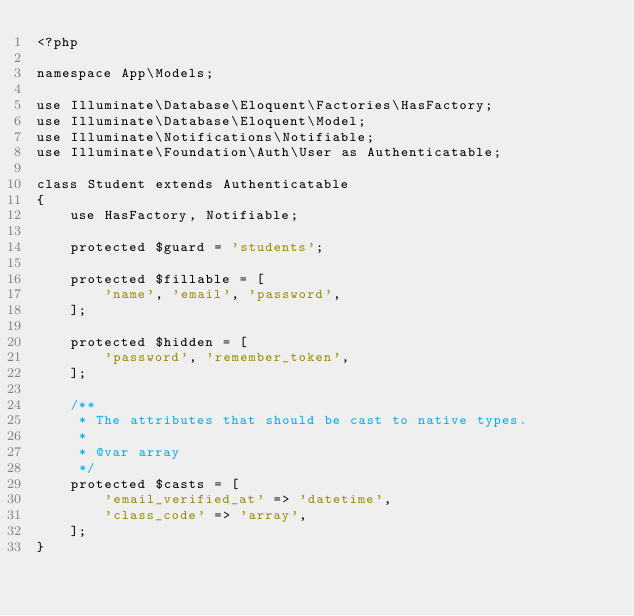<code> <loc_0><loc_0><loc_500><loc_500><_PHP_><?php

namespace App\Models;

use Illuminate\Database\Eloquent\Factories\HasFactory;
use Illuminate\Database\Eloquent\Model;
use Illuminate\Notifications\Notifiable;
use Illuminate\Foundation\Auth\User as Authenticatable;

class Student extends Authenticatable
{
    use HasFactory, Notifiable;

    protected $guard = 'students';

    protected $fillable = [
        'name', 'email', 'password',
    ];

    protected $hidden = [
        'password', 'remember_token',
    ];
    
    /**
     * The attributes that should be cast to native types.
     *
     * @var array
     */
    protected $casts = [
        'email_verified_at' => 'datetime',
        'class_code' => 'array',
    ];
}</code> 